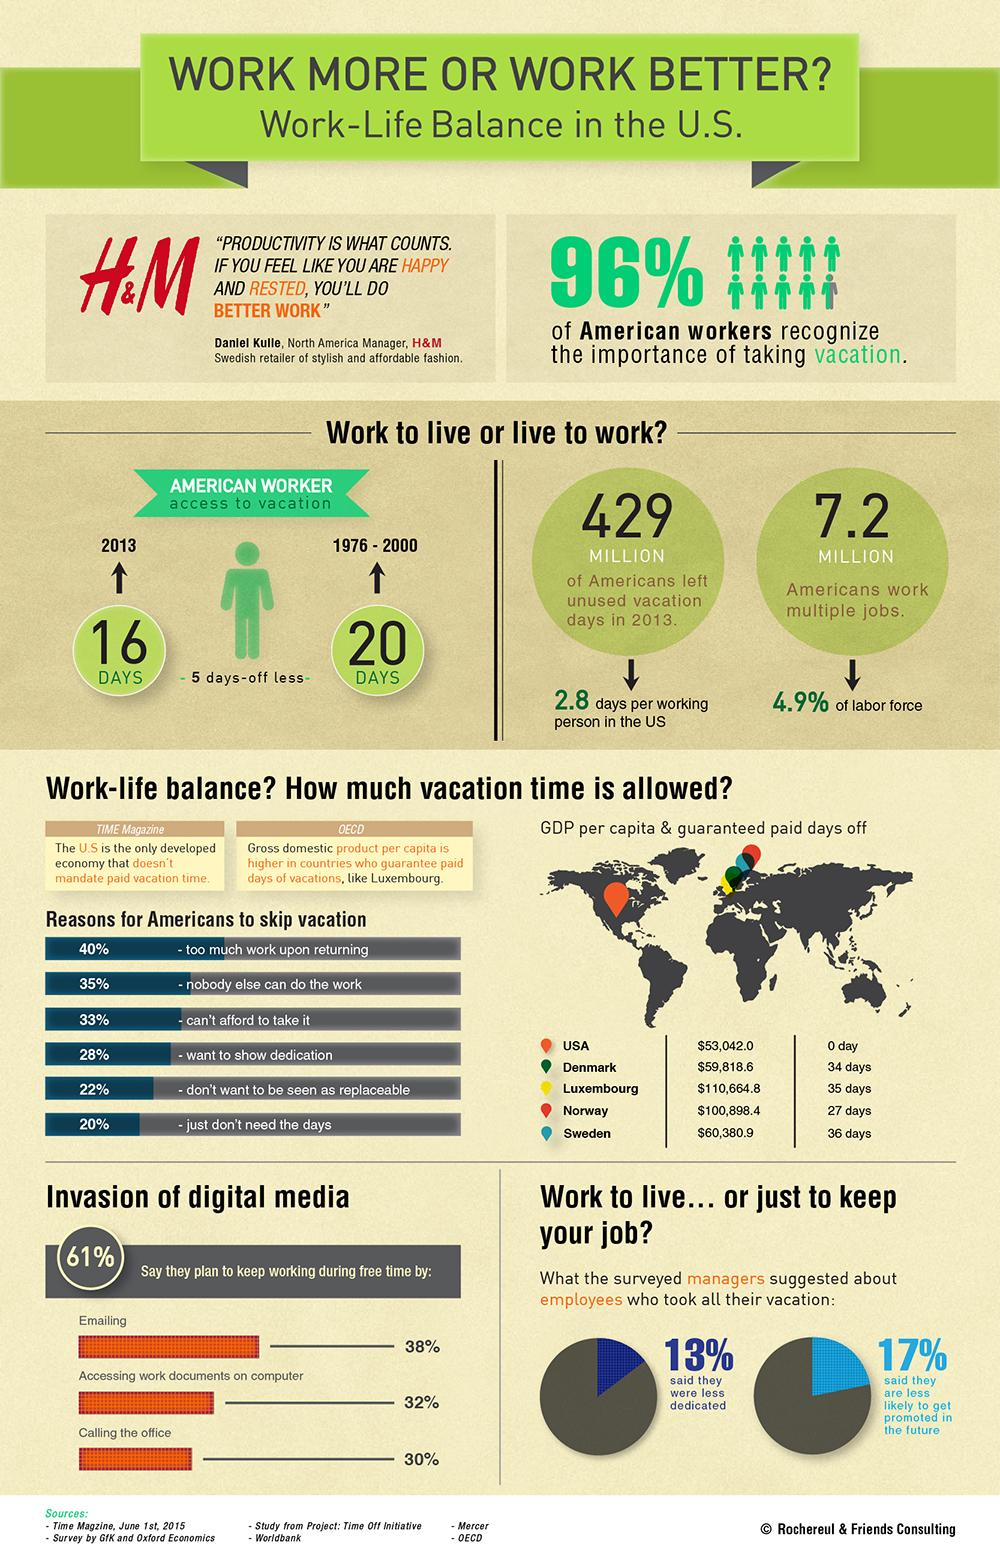Give some essential details in this illustration. Ninety-six percent of Americans recognize the importance of taking vacation, indicating a strong understanding of the benefits of rest and relaxation. According to recent estimates, approximately 7.2 million Americans hold down multiple jobs. In 2013, American workers took an average of 16 days of vacation, according to a recent study. According to a recent survey, approximately 40% of Americans skip taking a vacation due to work pressure after returning from their trip. In 2013, the estimated number of unused vacation days among the American population was 429 million. 